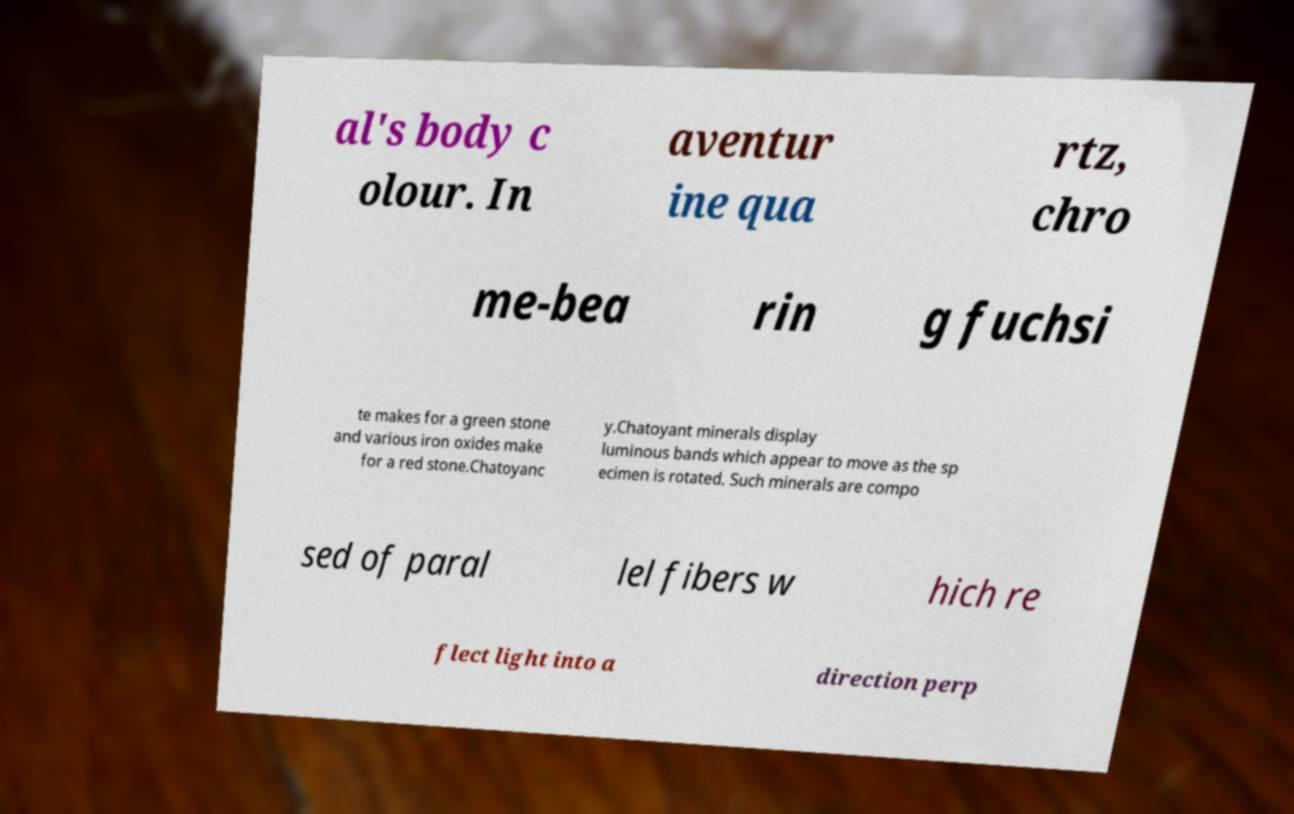Can you accurately transcribe the text from the provided image for me? al's body c olour. In aventur ine qua rtz, chro me-bea rin g fuchsi te makes for a green stone and various iron oxides make for a red stone.Chatoyanc y.Chatoyant minerals display luminous bands which appear to move as the sp ecimen is rotated. Such minerals are compo sed of paral lel fibers w hich re flect light into a direction perp 